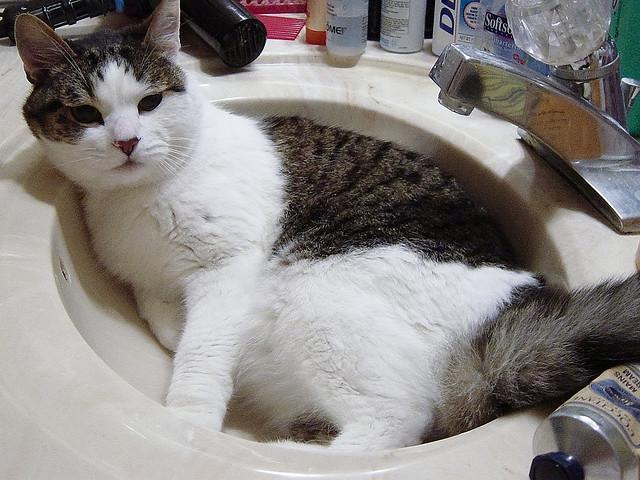How many bottles are in the photo?
Give a very brief answer. 3. 